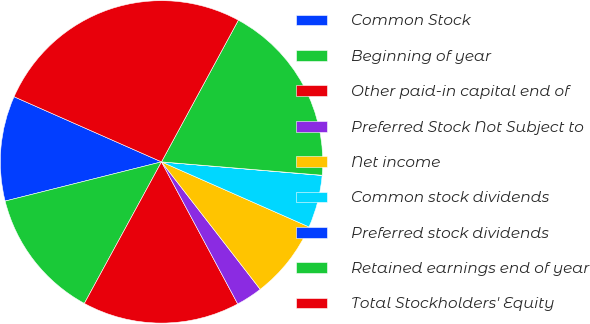Convert chart. <chart><loc_0><loc_0><loc_500><loc_500><pie_chart><fcel>Common Stock<fcel>Beginning of year<fcel>Other paid-in capital end of<fcel>Preferred Stock Not Subject to<fcel>Net income<fcel>Common stock dividends<fcel>Preferred stock dividends<fcel>Retained earnings end of year<fcel>Total Stockholders' Equity<nl><fcel>10.53%<fcel>13.15%<fcel>15.78%<fcel>2.65%<fcel>7.9%<fcel>5.27%<fcel>0.02%<fcel>18.41%<fcel>26.29%<nl></chart> 